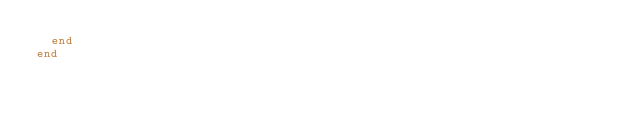<code> <loc_0><loc_0><loc_500><loc_500><_Ruby_>  end
end
</code> 